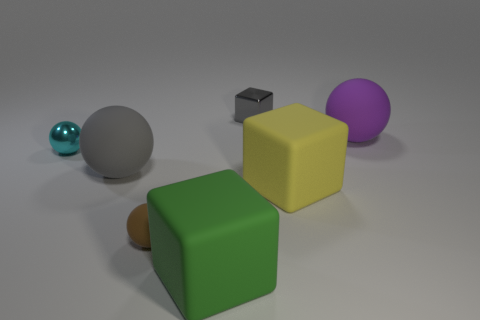There is a matte object that is the same color as the metal cube; what is its shape?
Offer a terse response. Sphere. Are there any metallic cylinders of the same size as the brown rubber object?
Ensure brevity in your answer.  No. There is a matte sphere that is behind the metal object that is on the left side of the small thing that is in front of the metal ball; what color is it?
Make the answer very short. Purple. Are the gray block and the small ball behind the big yellow object made of the same material?
Provide a succinct answer. Yes. What size is the gray rubber object that is the same shape as the purple matte thing?
Give a very brief answer. Large. Is the number of purple matte things that are in front of the tiny gray metallic thing the same as the number of green cubes behind the tiny cyan sphere?
Provide a succinct answer. No. What number of other things are made of the same material as the gray block?
Keep it short and to the point. 1. Are there the same number of cyan spheres that are to the right of the tiny cyan shiny ball and blue objects?
Your answer should be compact. Yes. Is the size of the brown matte ball the same as the matte sphere that is behind the small cyan ball?
Offer a very short reply. No. There is a large object in front of the large yellow matte cube; what shape is it?
Provide a succinct answer. Cube. 